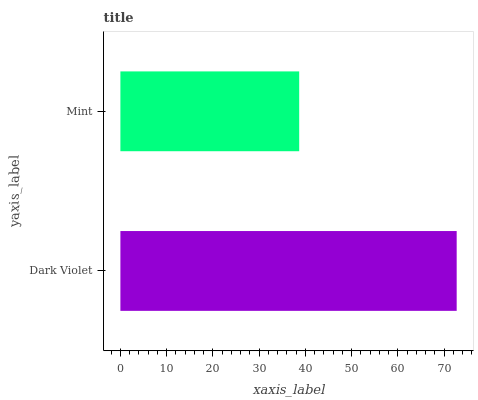Is Mint the minimum?
Answer yes or no. Yes. Is Dark Violet the maximum?
Answer yes or no. Yes. Is Mint the maximum?
Answer yes or no. No. Is Dark Violet greater than Mint?
Answer yes or no. Yes. Is Mint less than Dark Violet?
Answer yes or no. Yes. Is Mint greater than Dark Violet?
Answer yes or no. No. Is Dark Violet less than Mint?
Answer yes or no. No. Is Dark Violet the high median?
Answer yes or no. Yes. Is Mint the low median?
Answer yes or no. Yes. Is Mint the high median?
Answer yes or no. No. Is Dark Violet the low median?
Answer yes or no. No. 